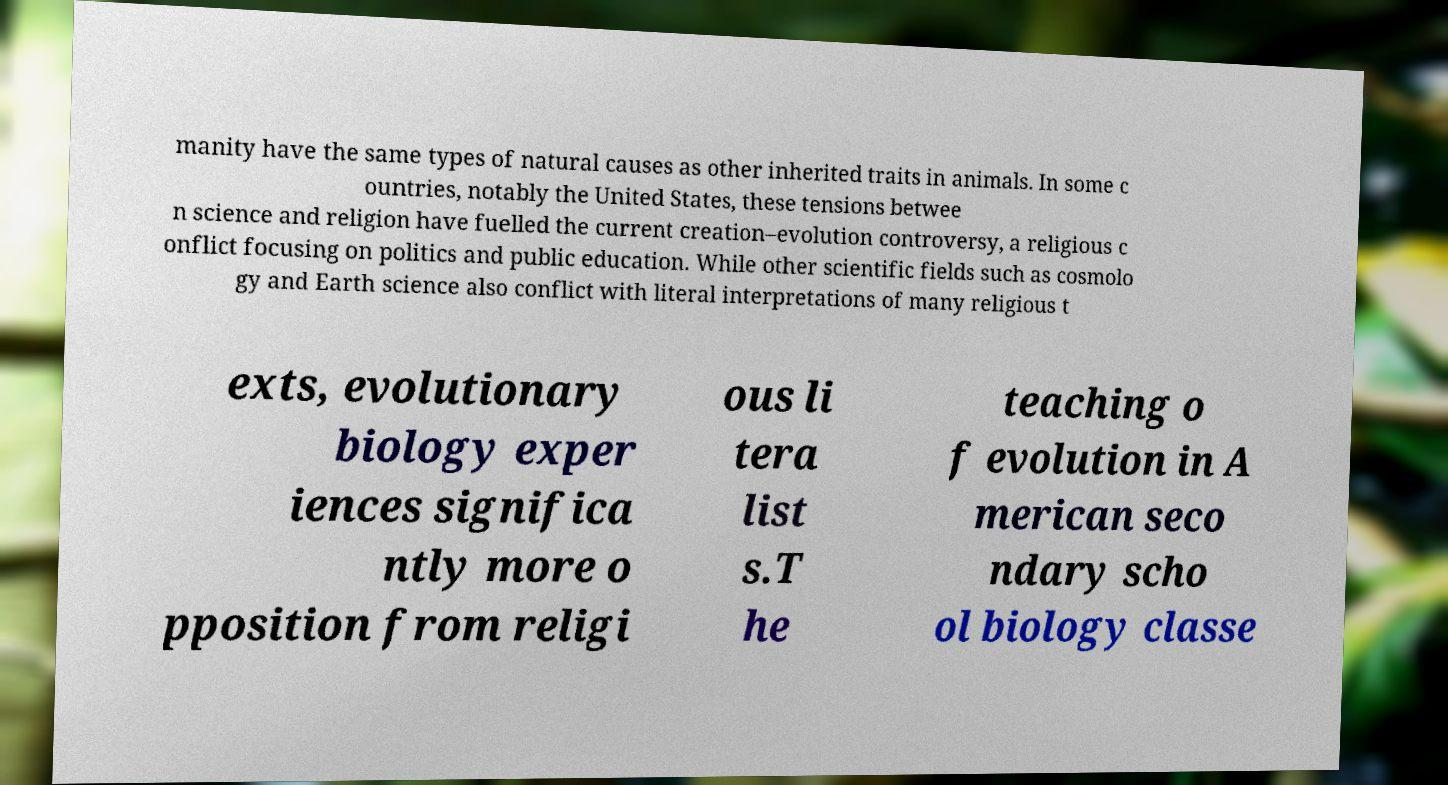For documentation purposes, I need the text within this image transcribed. Could you provide that? manity have the same types of natural causes as other inherited traits in animals. In some c ountries, notably the United States, these tensions betwee n science and religion have fuelled the current creation–evolution controversy, a religious c onflict focusing on politics and public education. While other scientific fields such as cosmolo gy and Earth science also conflict with literal interpretations of many religious t exts, evolutionary biology exper iences significa ntly more o pposition from religi ous li tera list s.T he teaching o f evolution in A merican seco ndary scho ol biology classe 